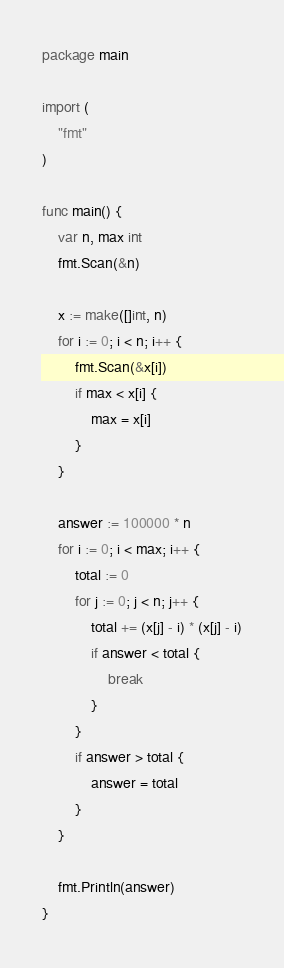<code> <loc_0><loc_0><loc_500><loc_500><_Go_>package main

import (
	"fmt"
)

func main() {
	var n, max int
	fmt.Scan(&n)

	x := make([]int, n)
	for i := 0; i < n; i++ {
		fmt.Scan(&x[i])
		if max < x[i] {
			max = x[i]
		}
	}

	answer := 100000 * n
	for i := 0; i < max; i++ {
		total := 0
		for j := 0; j < n; j++ {
			total += (x[j] - i) * (x[j] - i)
			if answer < total {
				break
			}
		}
		if answer > total {
			answer = total
		}
	}

	fmt.Println(answer)
}
</code> 